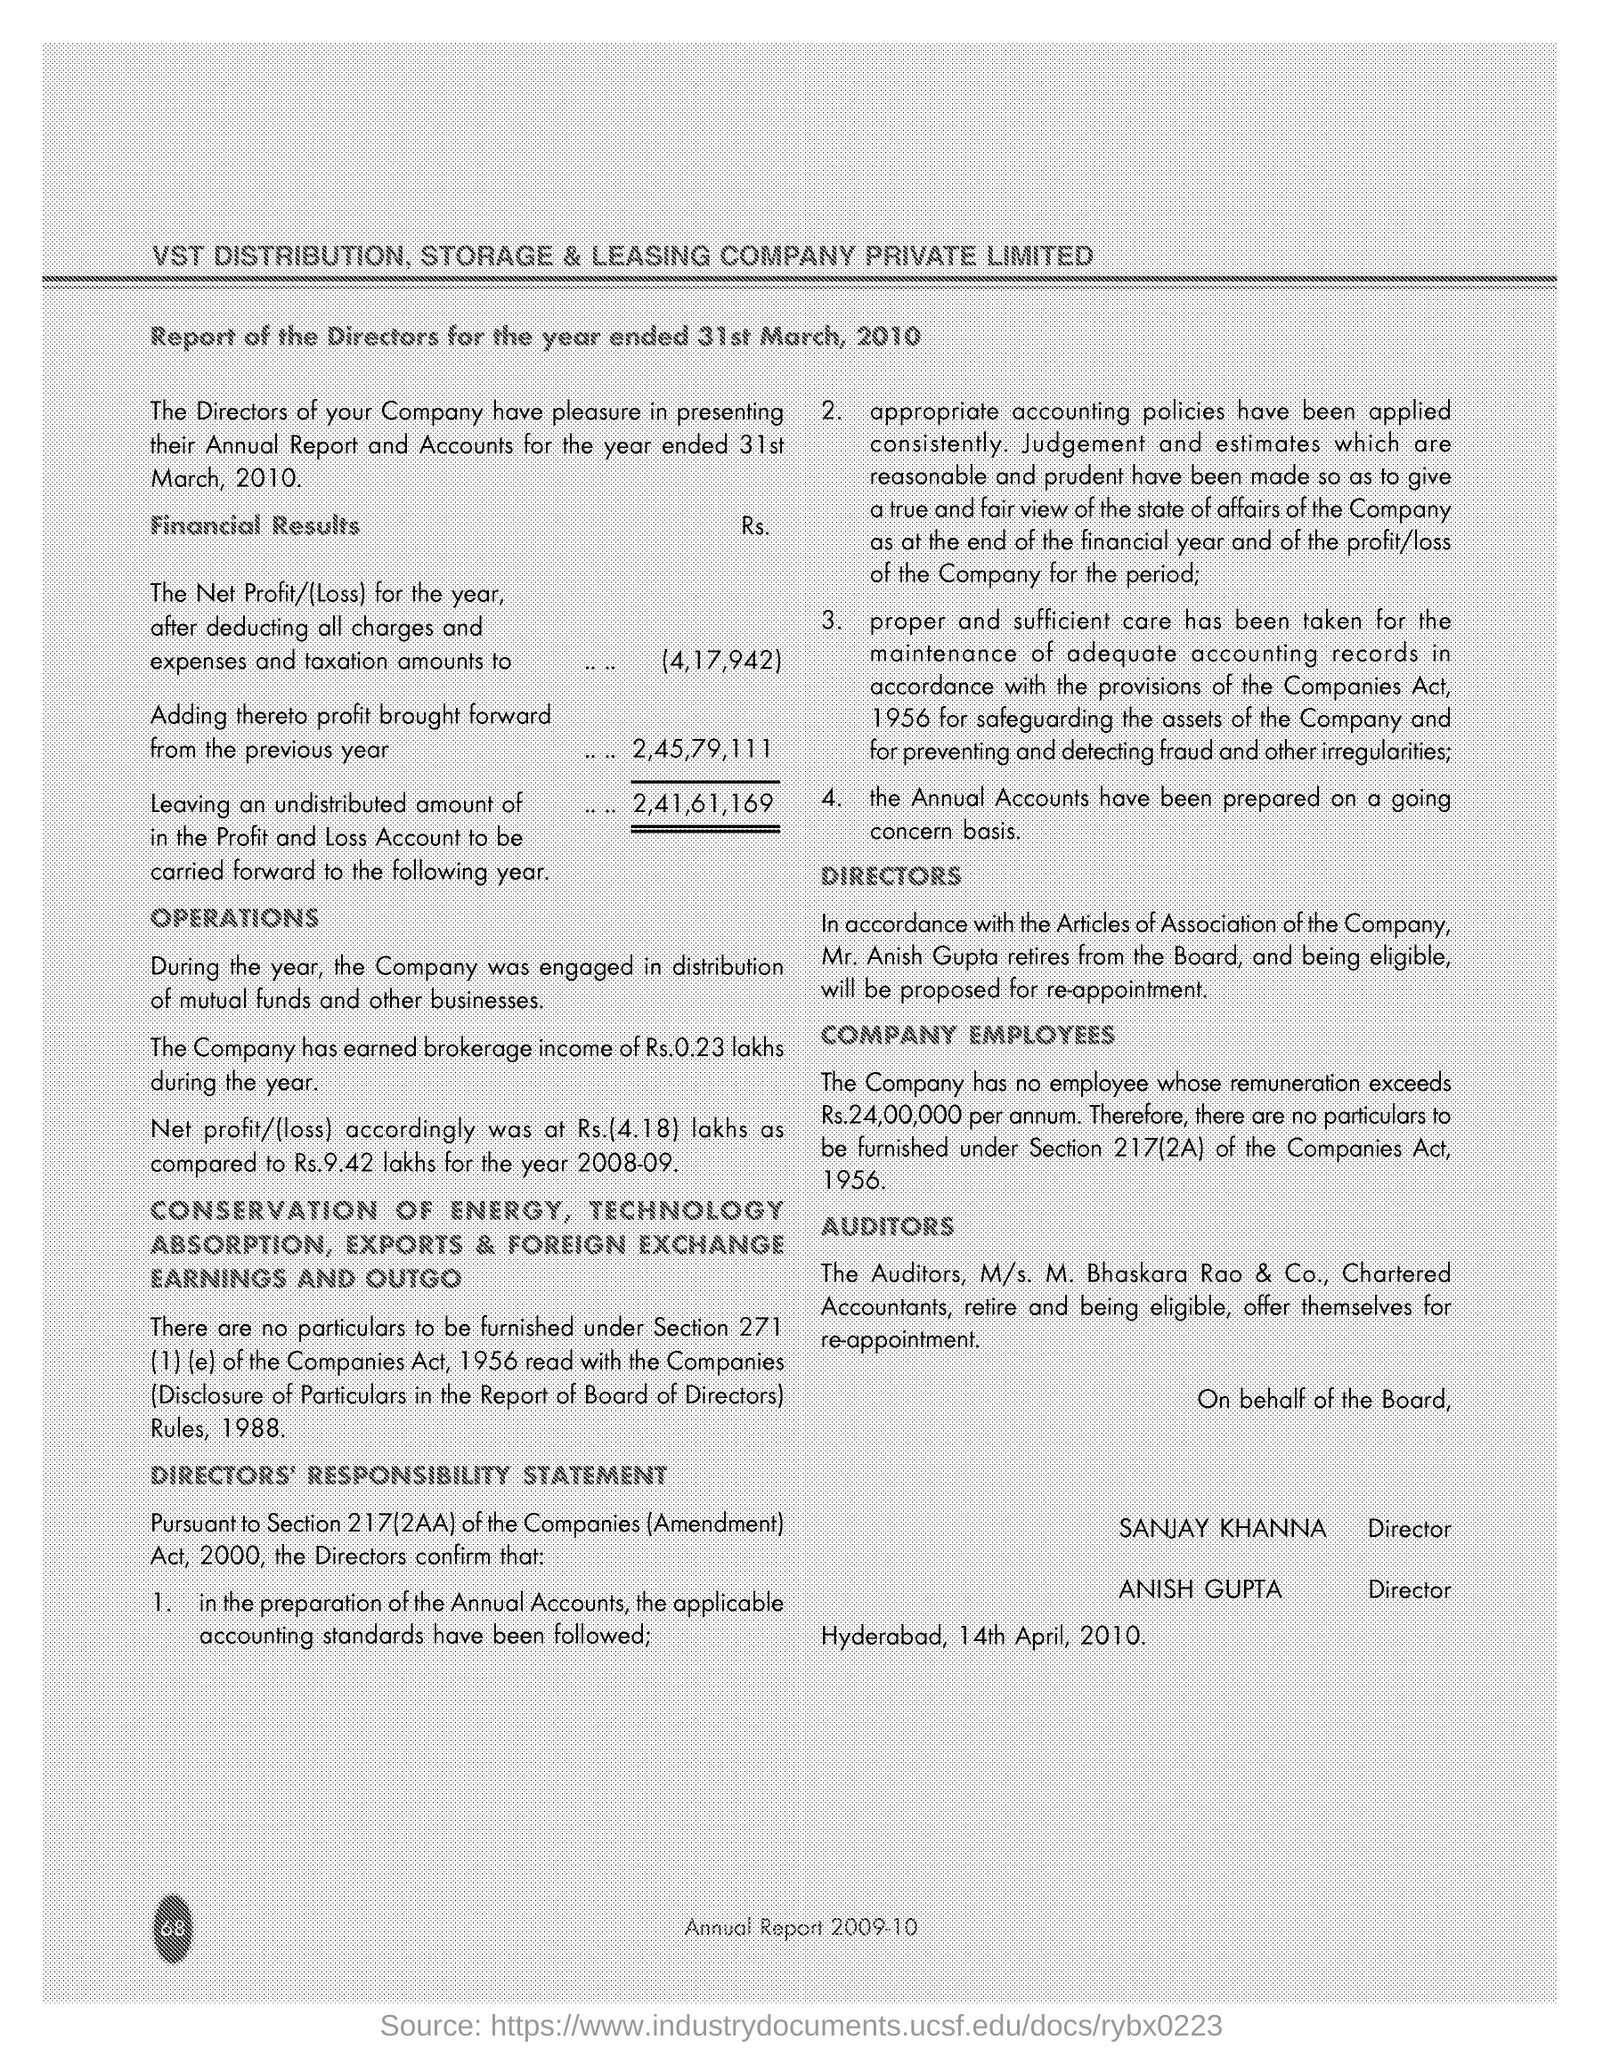Point out several critical features in this image. Anish Gupta has been designated as a Director. The net profit/loss for the year after deducting all charges, expenses, and taxation was 4,17,942. 